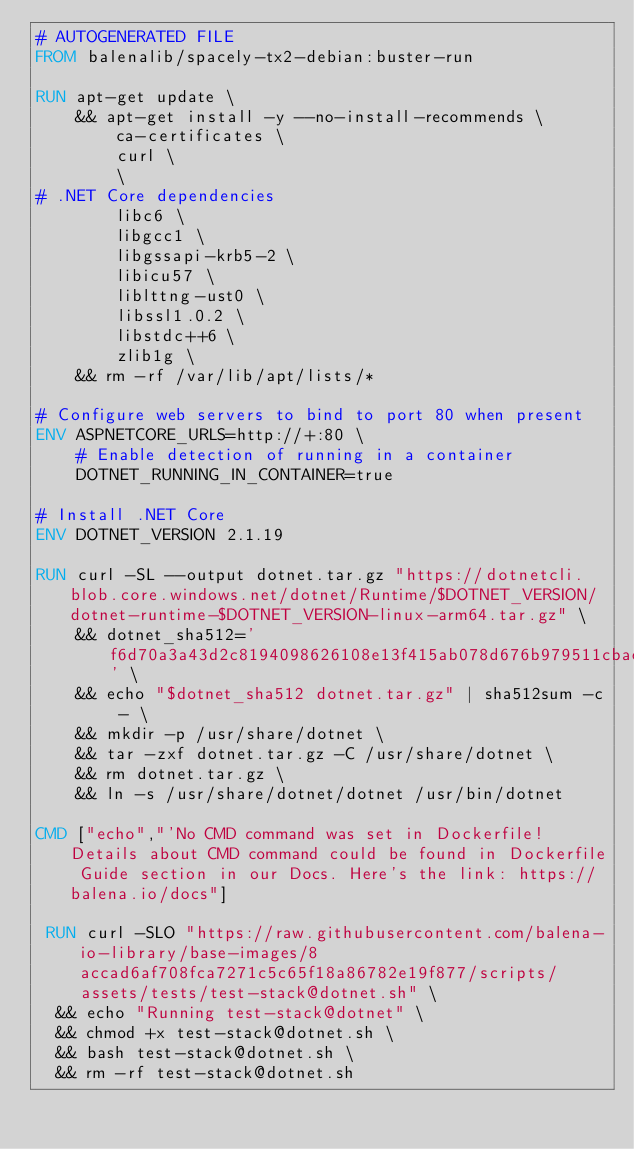Convert code to text. <code><loc_0><loc_0><loc_500><loc_500><_Dockerfile_># AUTOGENERATED FILE
FROM balenalib/spacely-tx2-debian:buster-run

RUN apt-get update \
    && apt-get install -y --no-install-recommends \
        ca-certificates \
        curl \
        \
# .NET Core dependencies
        libc6 \
        libgcc1 \
        libgssapi-krb5-2 \
        libicu57 \
        liblttng-ust0 \
        libssl1.0.2 \
        libstdc++6 \
        zlib1g \
    && rm -rf /var/lib/apt/lists/*

# Configure web servers to bind to port 80 when present
ENV ASPNETCORE_URLS=http://+:80 \
    # Enable detection of running in a container
    DOTNET_RUNNING_IN_CONTAINER=true

# Install .NET Core
ENV DOTNET_VERSION 2.1.19

RUN curl -SL --output dotnet.tar.gz "https://dotnetcli.blob.core.windows.net/dotnet/Runtime/$DOTNET_VERSION/dotnet-runtime-$DOTNET_VERSION-linux-arm64.tar.gz" \
    && dotnet_sha512='f6d70a3a43d2c8194098626108e13f415ab078d676b979511cbaebc388a471e3140f69ba7d312deeb951f57f7091b0e377870d7155cf643012a7541e0af0d918' \
    && echo "$dotnet_sha512 dotnet.tar.gz" | sha512sum -c - \
    && mkdir -p /usr/share/dotnet \
    && tar -zxf dotnet.tar.gz -C /usr/share/dotnet \
    && rm dotnet.tar.gz \
    && ln -s /usr/share/dotnet/dotnet /usr/bin/dotnet

CMD ["echo","'No CMD command was set in Dockerfile! Details about CMD command could be found in Dockerfile Guide section in our Docs. Here's the link: https://balena.io/docs"]

 RUN curl -SLO "https://raw.githubusercontent.com/balena-io-library/base-images/8accad6af708fca7271c5c65f18a86782e19f877/scripts/assets/tests/test-stack@dotnet.sh" \
  && echo "Running test-stack@dotnet" \
  && chmod +x test-stack@dotnet.sh \
  && bash test-stack@dotnet.sh \
  && rm -rf test-stack@dotnet.sh 
</code> 